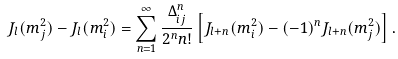Convert formula to latex. <formula><loc_0><loc_0><loc_500><loc_500>J _ { l } ( m _ { j } ^ { 2 } ) - J _ { l } ( m ^ { 2 } _ { i } ) = \sum ^ { \infty } _ { n = 1 } \frac { \Delta _ { i j } ^ { n } } { 2 ^ { n } n ! } \left [ J _ { l + n } ( m _ { i } ^ { 2 } ) - ( - 1 ) ^ { n } J _ { l + n } ( m _ { j } ^ { 2 } ) \right ] .</formula> 